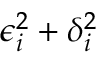Convert formula to latex. <formula><loc_0><loc_0><loc_500><loc_500>\epsilon _ { i } ^ { 2 } + \delta _ { i } ^ { 2 }</formula> 